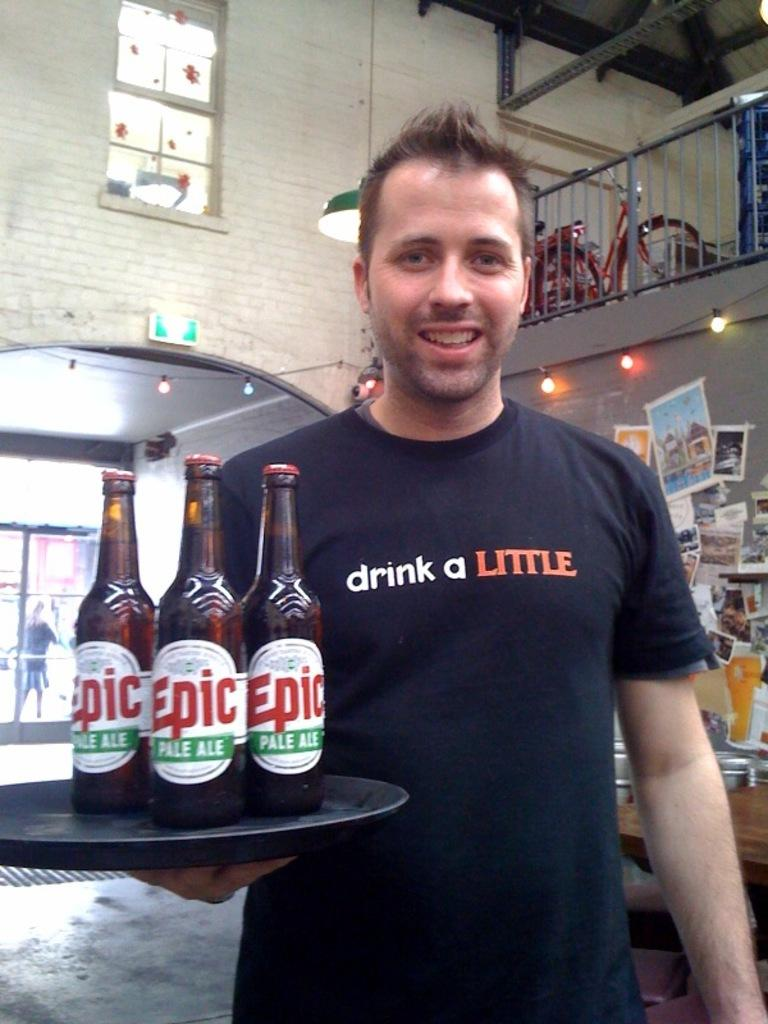<image>
Describe the image concisely. A man wearing a shirt which says drink a little is holding a tray with three bottles of Epic Pale Ale. 